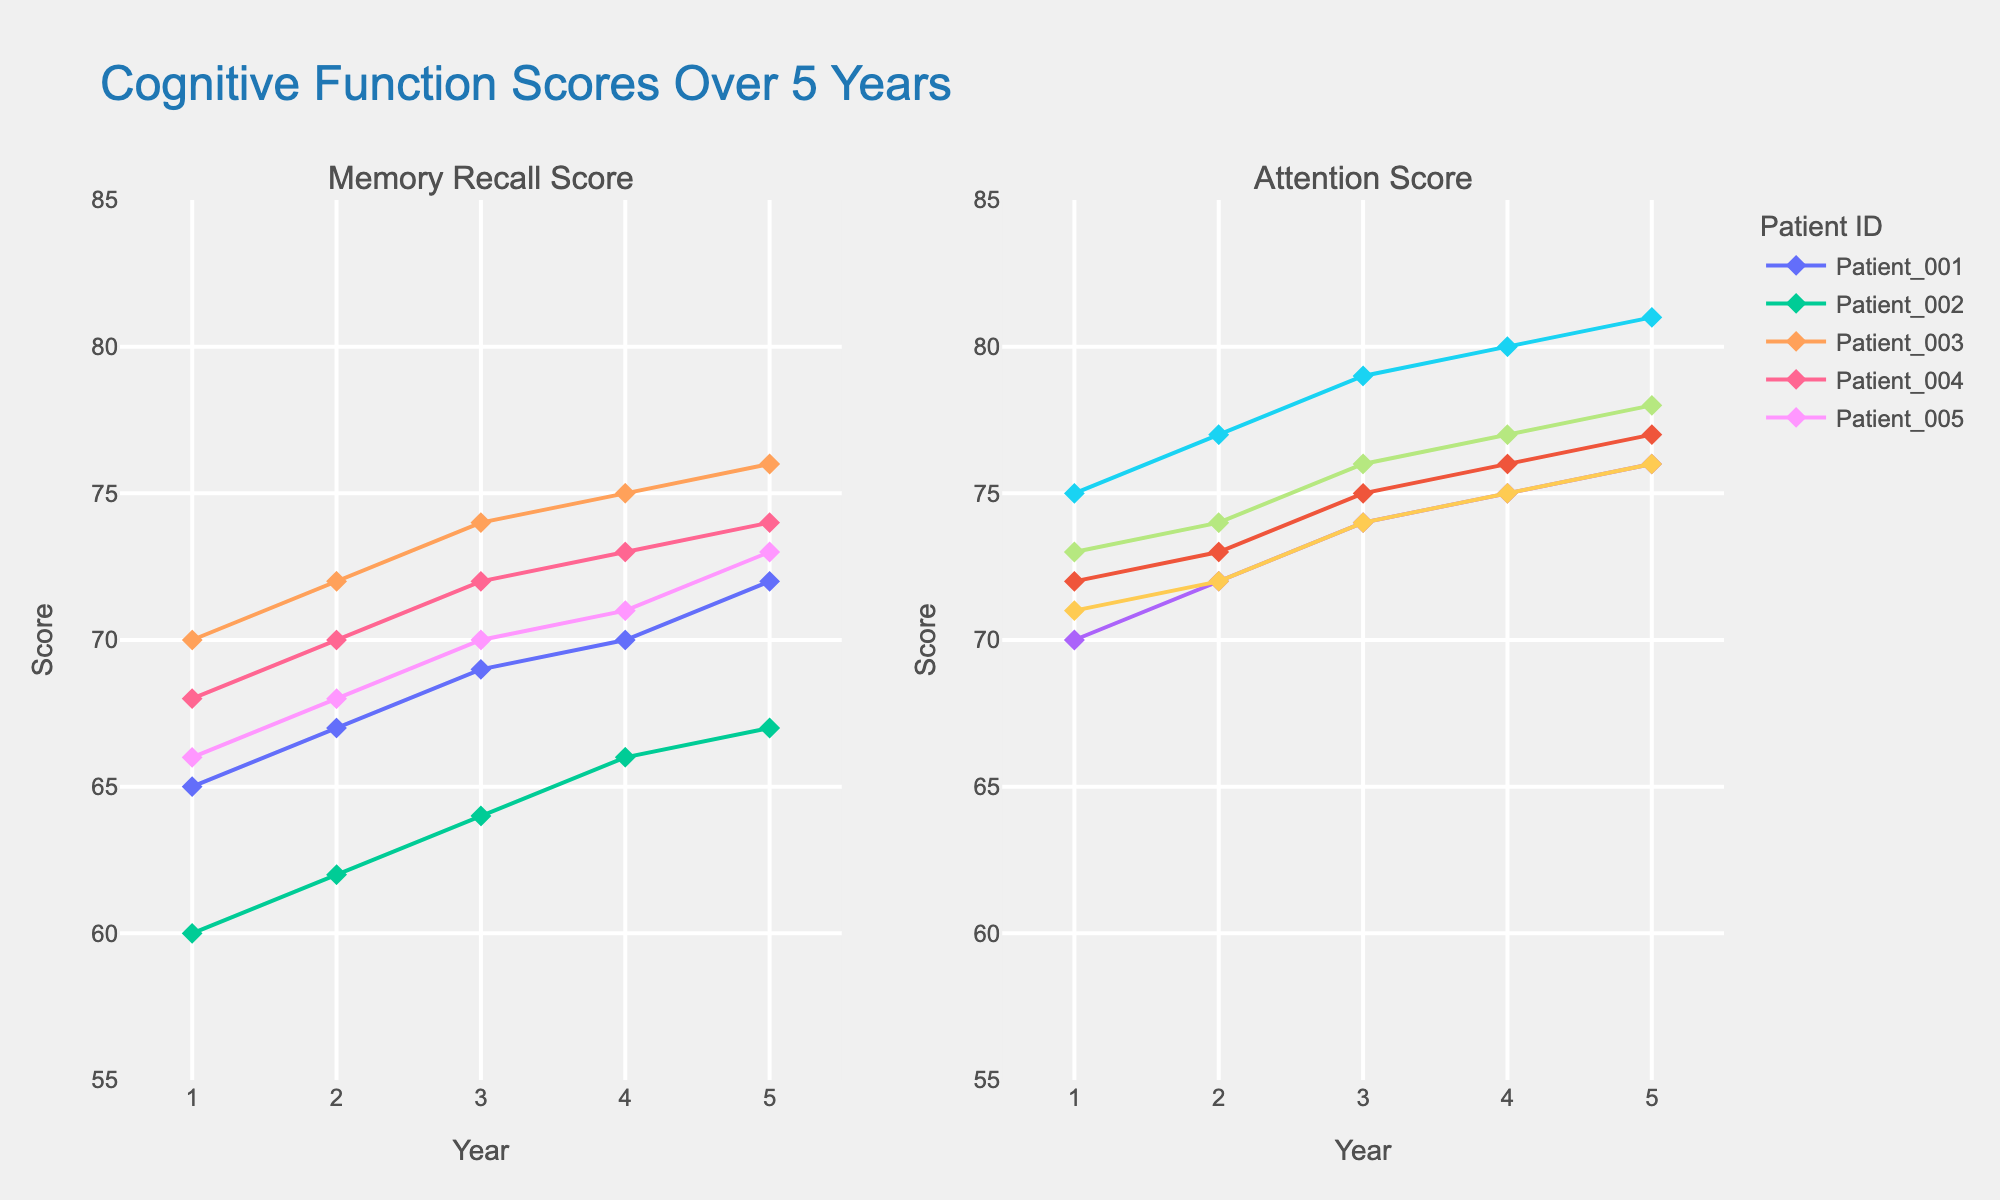How many patients are being tracked in the study? The figure shows lines for individual patients with unique identifiers such as Patient_001, Patient_002, etc. By counting these lines, we see that there are 5 patients.
Answer: 5 What are the axis labels in the plot? The plot has two subplots, both having their x-axis labeled "Year" and their y-axis labeled "Score". The left subplot addresses "Memory Recall Score" and the right one "Attention Score".
Answer: "Year" and "Score" What is the range of years covered in the plot? The x-axis ranges from Year 1 to Year 5, implying a span of 5 years.
Answer: Year 1 to Year 5 Which year shows the highest Memory Recall Score for Patient_003? By examining the trace for Patient_003 in the left subplot (Memory Recall Score), the highest value appears at Year 5 with a score of 76.
Answer: Year 5 What is the average Attention Score for Patient_001 over the 5 years? The values for Patient_001 are 72, 73, 75, 76, and 77. Summing these values gives 373, and dividing by 5 yields an average score of 74.6.
Answer: 74.6 How does the Attention Score of Patient_005 change from Year 1 to Year 5? In Year 1, Patient_005 has a score of 71, and in Year 5, the score is 76. This shows an increase of 5 points over the 5 years.
Answer: Increase by 5 points Is there a noticeable trend in Memory Recall Scores for any of the patients? By following the lines in the left subplot, we notice that all patients show a general upward trend in their Memory Recall Scores over the 5 years.
Answer: General upward trend Which patient has the least improvement in Attention Score over the years? By comparing the end and start scores in the right subplot for each patient, Patient_002 shows the least improvement—from 70 to 76—an increase of just 6 points.
Answer: Patient_002 What's the difference in Memory Recall Scores between Patient_002 and Patient_004 in Year 3? In Year 3, Patient_002’s score is 64, and Patient_004’s score is 72. The difference is 72 - 64 = 8 points.
Answer: 8 points 